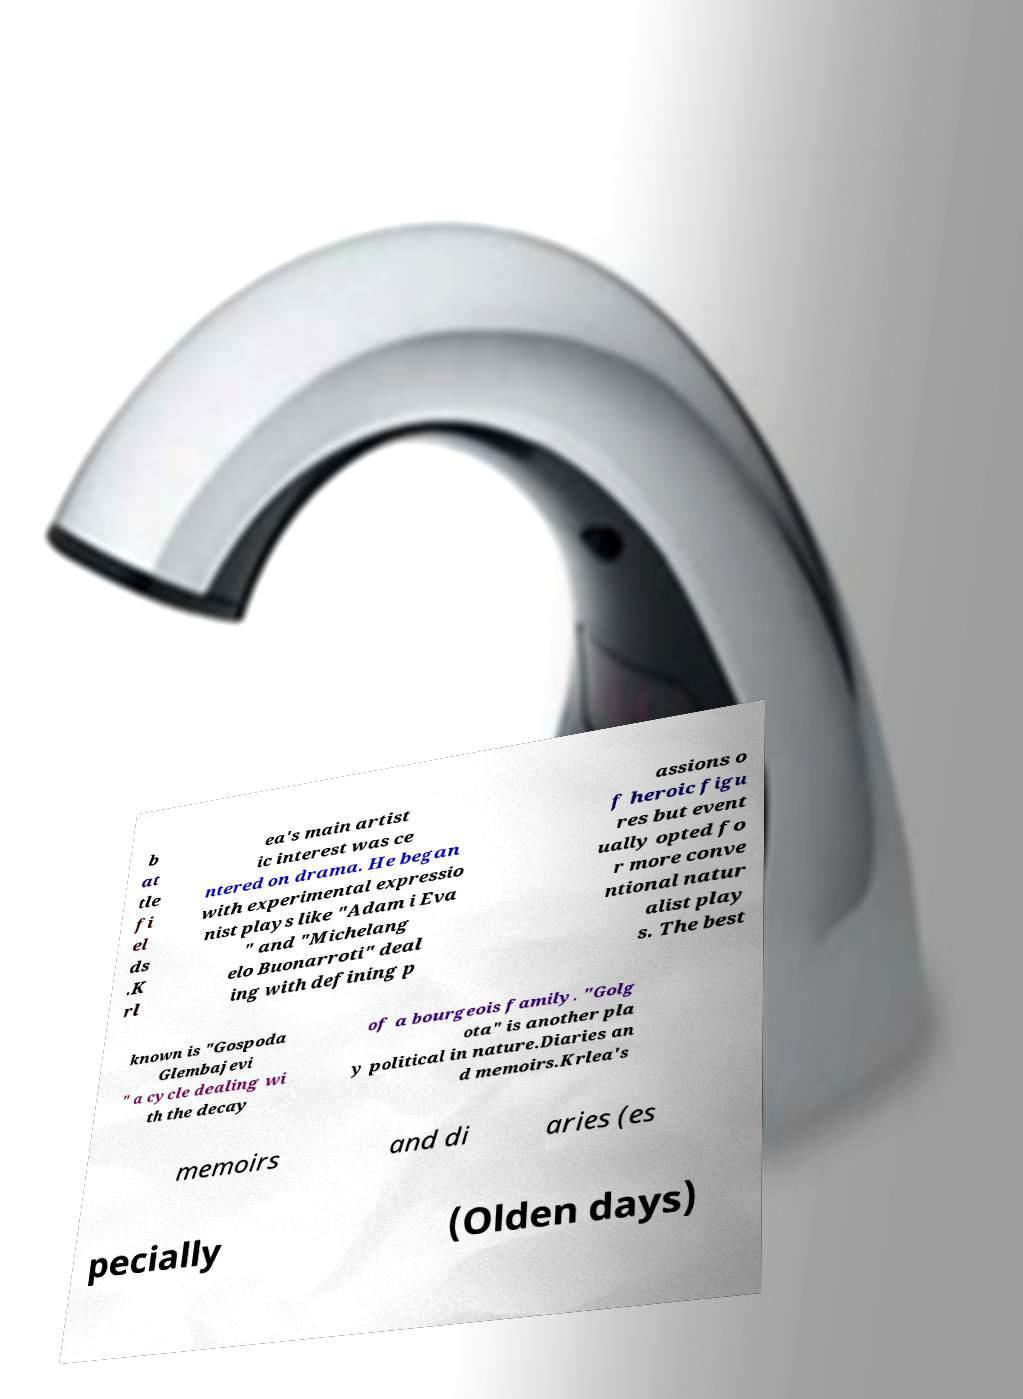Could you extract and type out the text from this image? b at tle fi el ds .K rl ea's main artist ic interest was ce ntered on drama. He began with experimental expressio nist plays like "Adam i Eva " and "Michelang elo Buonarroti" deal ing with defining p assions o f heroic figu res but event ually opted fo r more conve ntional natur alist play s. The best known is "Gospoda Glembajevi " a cycle dealing wi th the decay of a bourgeois family. "Golg ota" is another pla y political in nature.Diaries an d memoirs.Krlea's memoirs and di aries (es pecially (Olden days) 